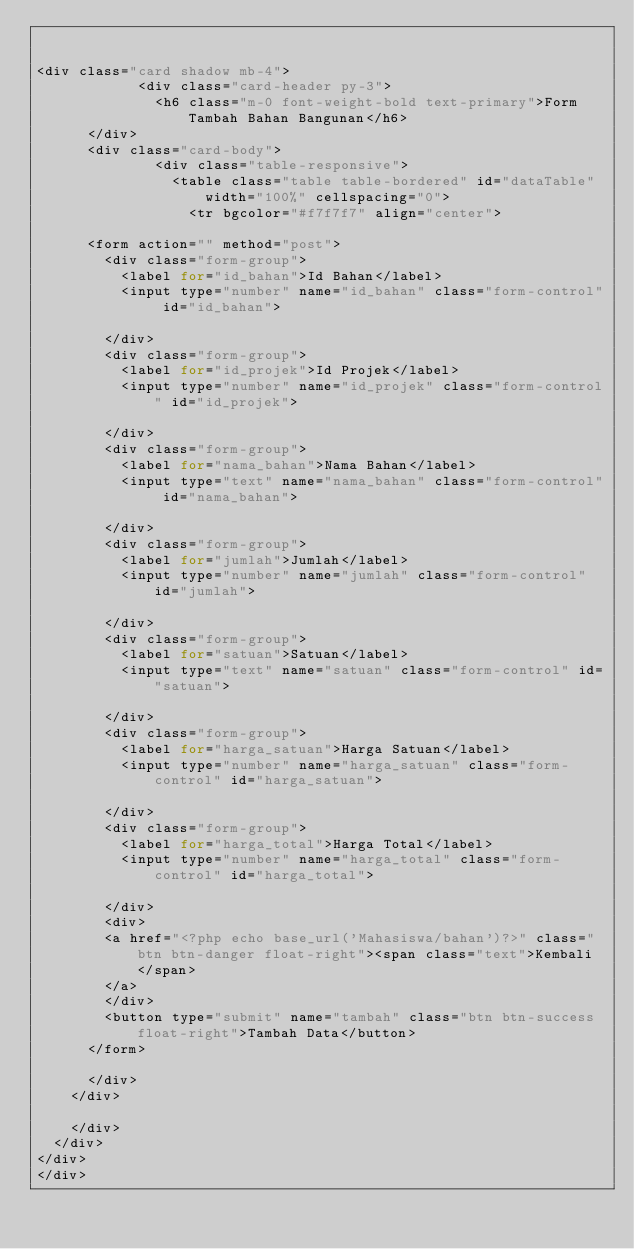<code> <loc_0><loc_0><loc_500><loc_500><_PHP_>

<div class="card shadow mb-4">
            <div class="card-header py-3">
              <h6 class="m-0 font-weight-bold text-primary">Form Tambah Bahan Bangunan</h6>
			</div>
			<div class="card-body">
              <div class="table-responsive">
                <table class="table table-bordered" id="dataTable" width="100%" cellspacing="0">
                  <tr bgcolor="#f7f7f7" align="center">
                  	
			<form action="" method="post">
				<div class="form-group">
					<label for="id_bahan">Id Bahan</label>
					<input type="number" name="id_bahan" class="form-control" id="id_bahan">
					
				</div>
				<div class="form-group">
					<label for="id_projek">Id Projek</label>
					<input type="number" name="id_projek" class="form-control" id="id_projek">
					
				</div>
				<div class="form-group">
					<label for="nama_bahan">Nama Bahan</label>
					<input type="text" name="nama_bahan" class="form-control" id="nama_bahan">
					
				</div>
				<div class="form-group">
					<label for="jumlah">Jumlah</label>
					<input type="number" name="jumlah" class="form-control" id="jumlah">
					
				</div>
				<div class="form-group">
					<label for="satuan">Satuan</label>
					<input type="text" name="satuan" class="form-control" id="satuan">
					
				</div>
				<div class="form-group">
					<label for="harga_satuan">Harga Satuan</label>
					<input type="number" name="harga_satuan" class="form-control" id="harga_satuan">
					
				</div>
				<div class="form-group">
					<label for="harga_total">Harga Total</label>
					<input type="number" name="harga_total" class="form-control" id="harga_total">
					
				</div>
				<div>
				<a href="<?php echo base_url('Mahasiswa/bahan')?>" class="btn btn-danger float-right"><span class="text">Kembali</span>
				</a>
				</div>
				<button type="submit" name="tambah" class="btn btn-success float-right">Tambah Data</button>
			</form>	
				
			</div>
		</div>
			
		</div>
	</div>
</div>
</div></code> 